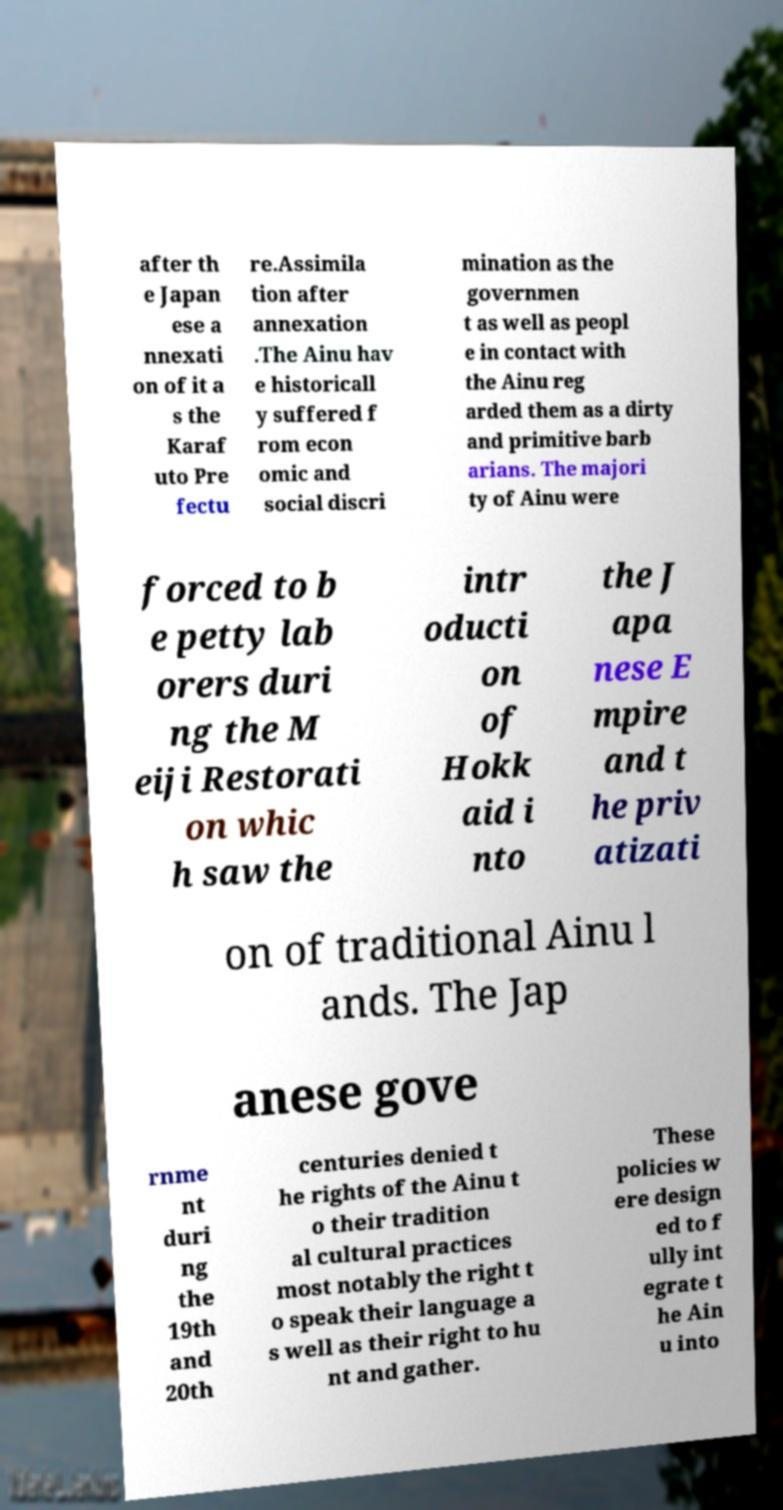For documentation purposes, I need the text within this image transcribed. Could you provide that? after th e Japan ese a nnexati on of it a s the Karaf uto Pre fectu re.Assimila tion after annexation .The Ainu hav e historicall y suffered f rom econ omic and social discri mination as the governmen t as well as peopl e in contact with the Ainu reg arded them as a dirty and primitive barb arians. The majori ty of Ainu were forced to b e petty lab orers duri ng the M eiji Restorati on whic h saw the intr oducti on of Hokk aid i nto the J apa nese E mpire and t he priv atizati on of traditional Ainu l ands. The Jap anese gove rnme nt duri ng the 19th and 20th centuries denied t he rights of the Ainu t o their tradition al cultural practices most notably the right t o speak their language a s well as their right to hu nt and gather. These policies w ere design ed to f ully int egrate t he Ain u into 